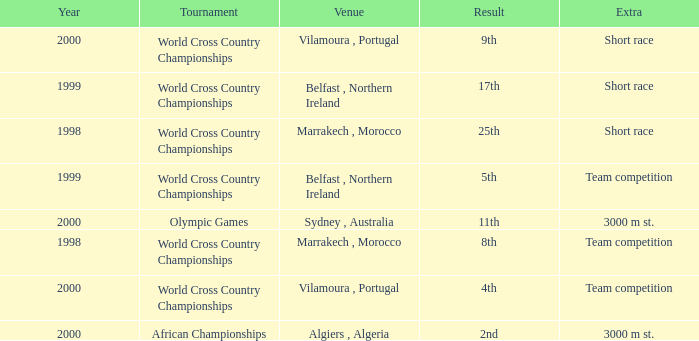Tell me the extra for tournament of olympic games 3000 m st. 